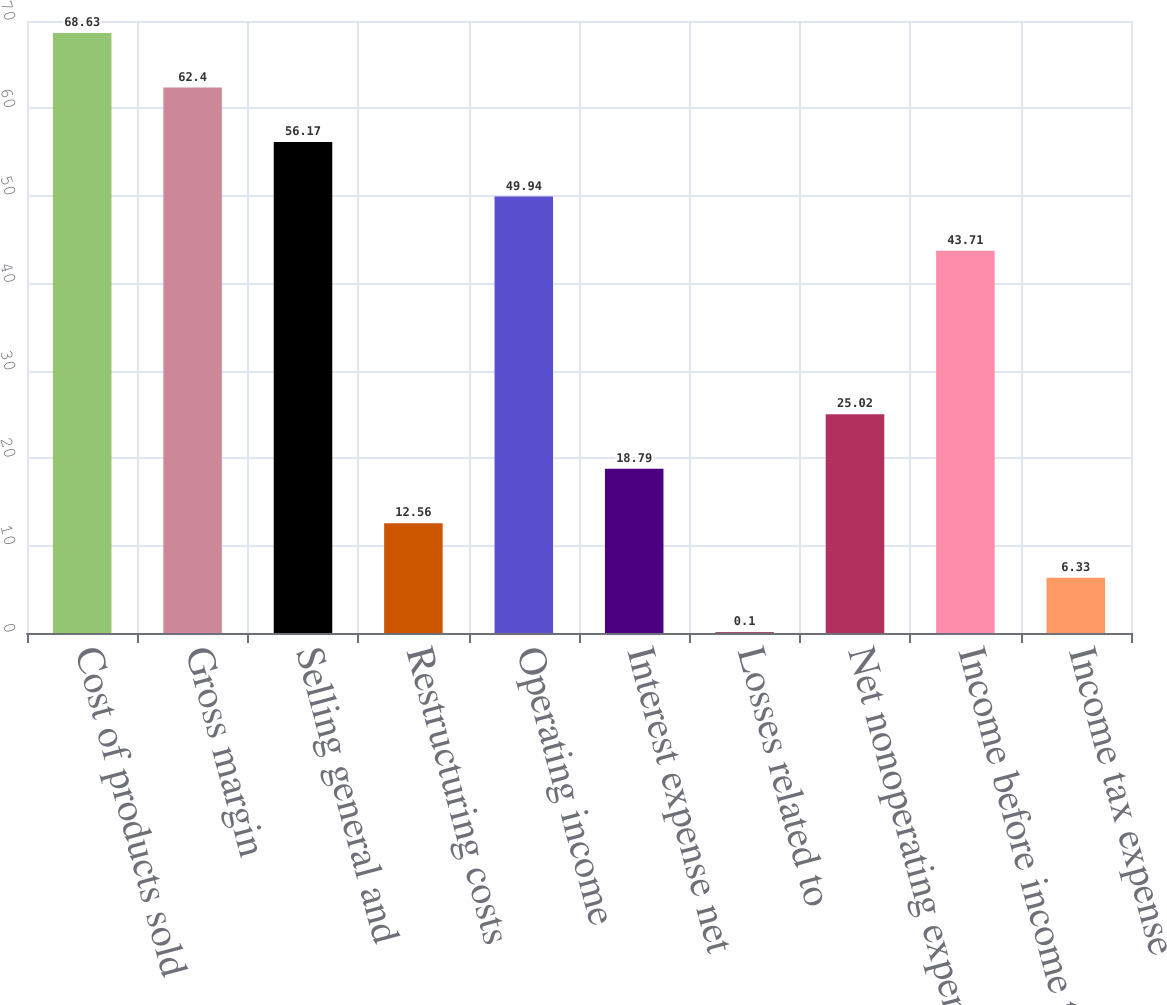Convert chart. <chart><loc_0><loc_0><loc_500><loc_500><bar_chart><fcel>Cost of products sold<fcel>Gross margin<fcel>Selling general and<fcel>Restructuring costs<fcel>Operating income<fcel>Interest expense net<fcel>Losses related to<fcel>Net nonoperating expenses<fcel>Income before income taxes<fcel>Income tax expense<nl><fcel>68.63<fcel>62.4<fcel>56.17<fcel>12.56<fcel>49.94<fcel>18.79<fcel>0.1<fcel>25.02<fcel>43.71<fcel>6.33<nl></chart> 